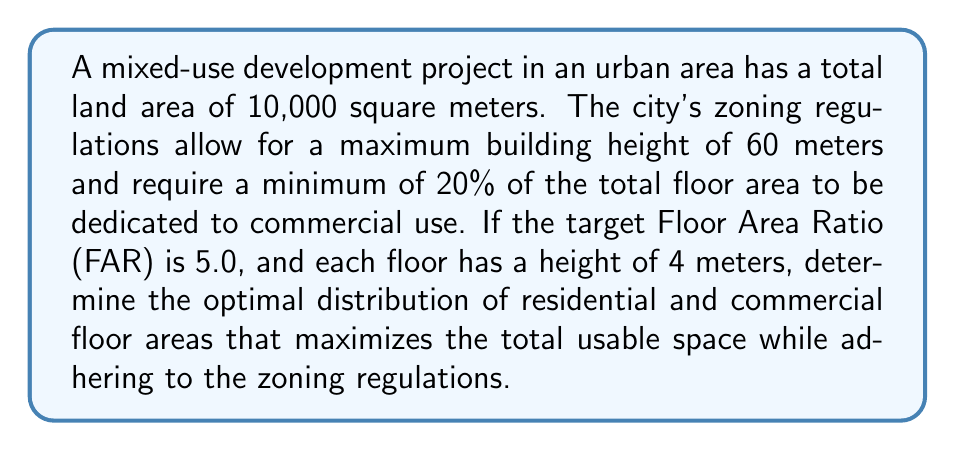Help me with this question. To solve this problem, we need to follow these steps:

1. Calculate the total allowable floor area:
   FAR = Total Floor Area / Land Area
   $5.0 = \text{Total Floor Area} / 10,000 \text{ m}^2$
   Total Floor Area = $5.0 \times 10,000 = 50,000 \text{ m}^2$

2. Determine the maximum number of floors:
   Maximum building height = 60 m
   Floor height = 4 m
   Maximum number of floors = $60 \text{ m} / 4 \text{ m} = 15$ floors

3. Calculate the minimum required commercial floor area:
   Minimum commercial area = 20% of total floor area
   $0.20 \times 50,000 \text{ m}^2 = 10,000 \text{ m}^2$

4. Determine the remaining area for residential use:
   Residential area = Total floor area - Commercial area
   $50,000 \text{ m}^2 - 10,000 \text{ m}^2 = 40,000 \text{ m}^2$

5. Optimize the distribution:
   To maximize usable space, we should use the full 15 floors allowed.
   Floor area per level = $50,000 \text{ m}^2 / 15 = 3,333.33 \text{ m}^2$

   Commercial floors needed = $10,000 \text{ m}^2 / 3,333.33 \text{ m}^2 \approx 3$ floors
   Residential floors = $15 - 3 = 12$ floors

   Actual commercial area = $3 \times 3,333.33 \text{ m}^2 = 10,000 \text{ m}^2$
   Actual residential area = $12 \times 3,333.33 \text{ m}^2 = 40,000 \text{ m}^2$

This distribution satisfies the minimum commercial area requirement and maximizes the use of available floor space.
Answer: The optimal distribution is 3 floors of commercial space (10,000 m²) and 12 floors of residential space (40,000 m²), totaling 15 floors with a floor area of 3,333.33 m² per level. 